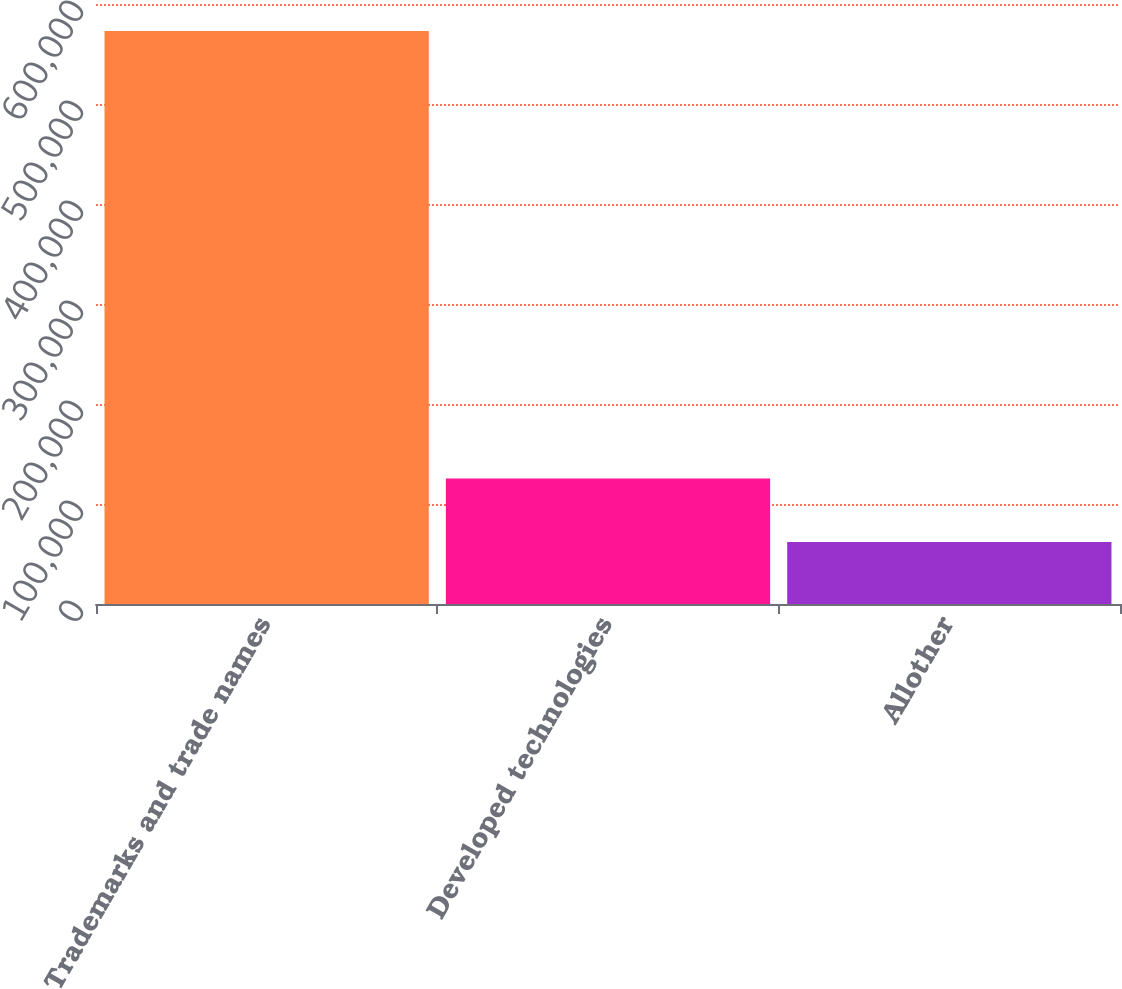Convert chart to OTSL. <chart><loc_0><loc_0><loc_500><loc_500><bar_chart><fcel>Trademarks and trade names<fcel>Developed technologies<fcel>Allother<nl><fcel>572918<fcel>125504<fcel>62052<nl></chart> 